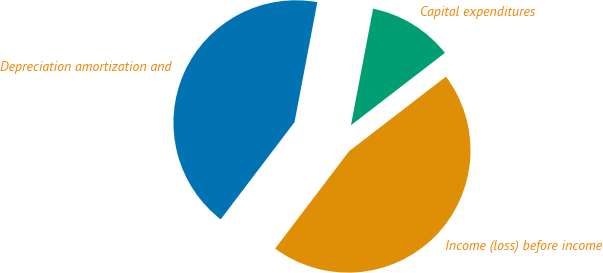Convert chart to OTSL. <chart><loc_0><loc_0><loc_500><loc_500><pie_chart><fcel>Depreciation amortization and<fcel>Income (loss) before income<fcel>Capital expenditures<nl><fcel>42.65%<fcel>45.78%<fcel>11.57%<nl></chart> 